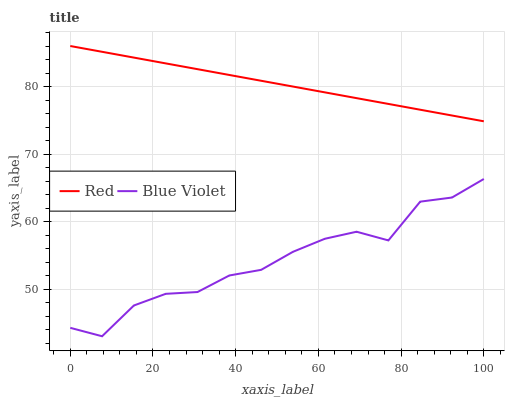Does Blue Violet have the minimum area under the curve?
Answer yes or no. Yes. Does Red have the maximum area under the curve?
Answer yes or no. Yes. Does Red have the minimum area under the curve?
Answer yes or no. No. Is Red the smoothest?
Answer yes or no. Yes. Is Blue Violet the roughest?
Answer yes or no. Yes. Is Red the roughest?
Answer yes or no. No. Does Blue Violet have the lowest value?
Answer yes or no. Yes. Does Red have the lowest value?
Answer yes or no. No. Does Red have the highest value?
Answer yes or no. Yes. Is Blue Violet less than Red?
Answer yes or no. Yes. Is Red greater than Blue Violet?
Answer yes or no. Yes. Does Blue Violet intersect Red?
Answer yes or no. No. 